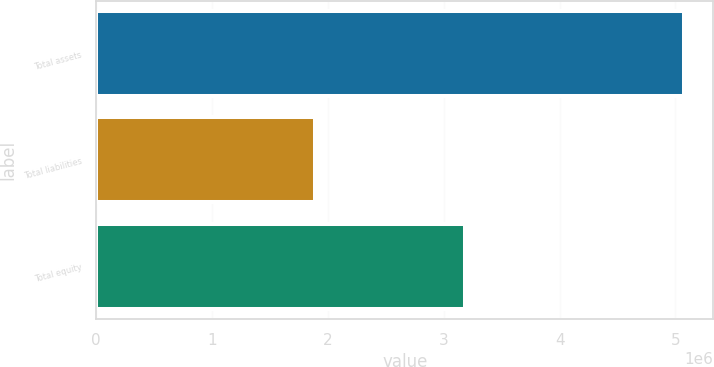Convert chart to OTSL. <chart><loc_0><loc_0><loc_500><loc_500><bar_chart><fcel>Total assets<fcel>Total liabilities<fcel>Total equity<nl><fcel>5.07307e+06<fcel>1.88727e+06<fcel>3.1858e+06<nl></chart> 